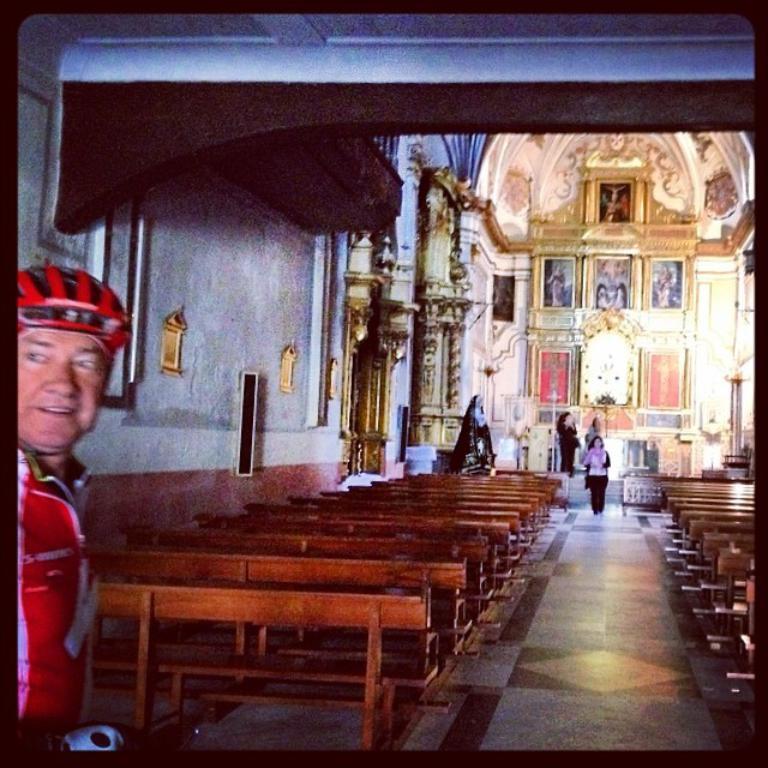Could you give a brief overview of what you see in this image? In this image I can see benches visible on the floor and I can see a person visible in the middle and I can see a colorful design wall visible on the right side and on the left side I can see a person wearing a colorful t-shirt. 